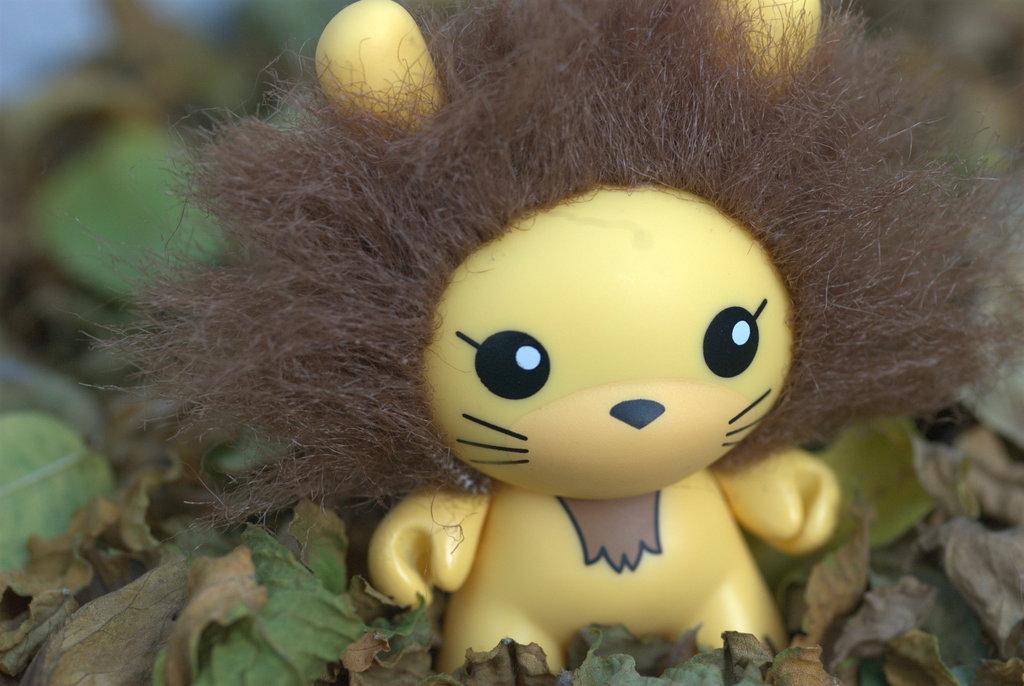What object in the image is designed for play or amusement? There is a toy in the image. What type of natural elements can be seen in the image? There are leaves in the image. Where is the cactus located in the image? There is no cactus present in the image. What type of adhesive can be seen in the image? There is no glue present in the image. 